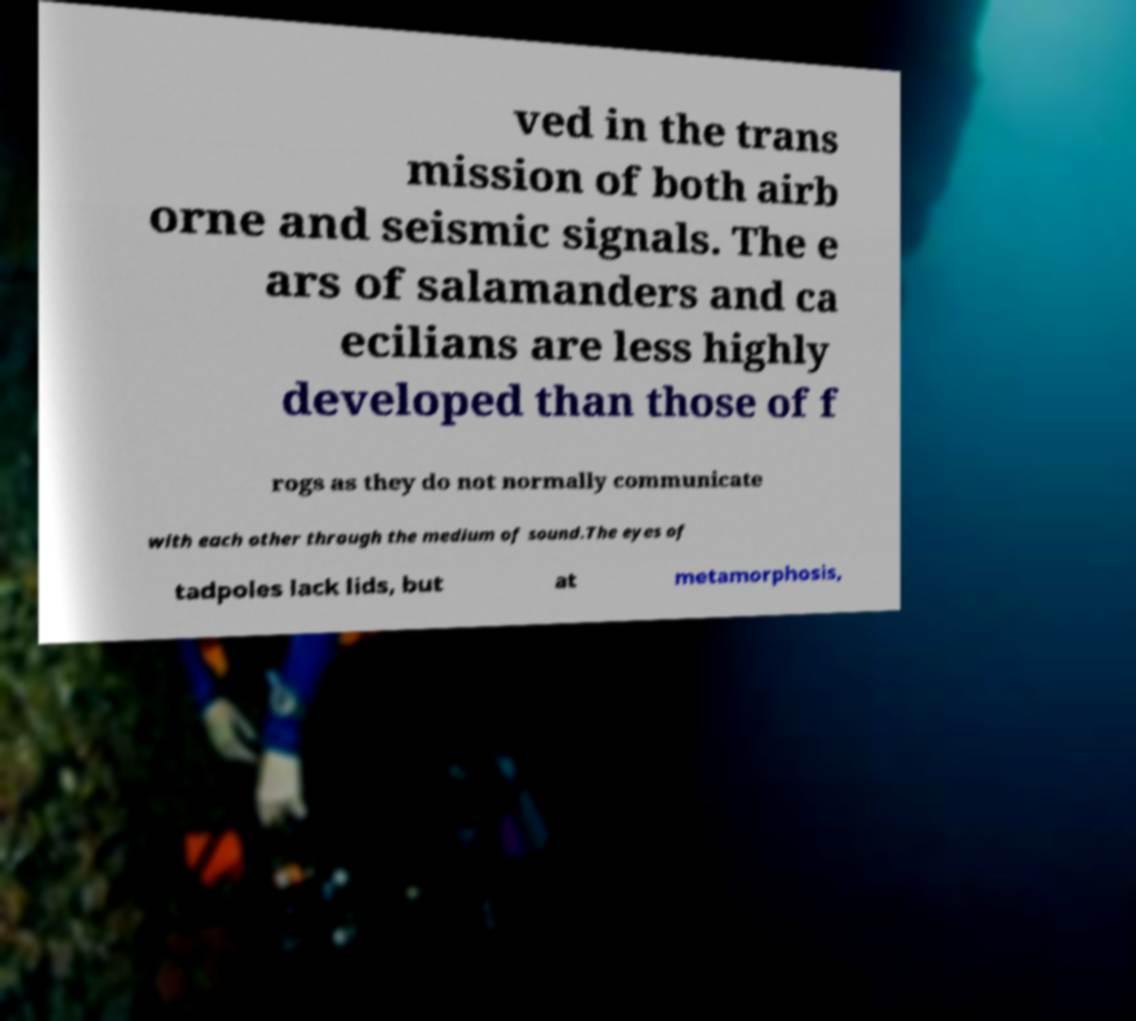Can you accurately transcribe the text from the provided image for me? ved in the trans mission of both airb orne and seismic signals. The e ars of salamanders and ca ecilians are less highly developed than those of f rogs as they do not normally communicate with each other through the medium of sound.The eyes of tadpoles lack lids, but at metamorphosis, 